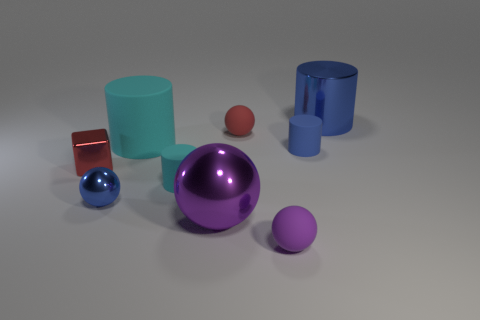Are there an equal number of large purple shiny things that are to the left of the large matte object and large things that are behind the large sphere?
Offer a very short reply. No. How many small purple spheres have the same material as the blue ball?
Your answer should be compact. 0. The tiny object that is the same color as the cube is what shape?
Make the answer very short. Sphere. What is the size of the metallic thing that is to the right of the matte sphere behind the purple rubber ball?
Keep it short and to the point. Large. Does the tiny blue object right of the purple matte sphere have the same shape as the large blue shiny object that is behind the red metal cube?
Offer a terse response. Yes. Is the number of small blue matte objects to the left of the large ball the same as the number of big cyan matte blocks?
Ensure brevity in your answer.  Yes. There is a large metallic object that is the same shape as the large matte object; what color is it?
Ensure brevity in your answer.  Blue. Does the small blue object that is left of the small cyan thing have the same material as the small purple object?
Offer a very short reply. No. How many tiny objects are either metallic cylinders or brown objects?
Your answer should be very brief. 0. The shiny cylinder has what size?
Give a very brief answer. Large. 